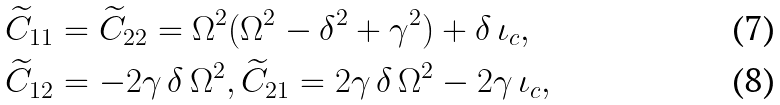Convert formula to latex. <formula><loc_0><loc_0><loc_500><loc_500>\widetilde { C } _ { 1 1 } & = \widetilde { C } _ { 2 2 } = \Omega ^ { 2 } ( \Omega ^ { 2 } - \delta ^ { 2 } + \gamma ^ { 2 } ) + \delta \, \iota _ { c } , \\ \widetilde { C } _ { 1 2 } & = - 2 \gamma \, \delta \, \Omega ^ { 2 } , \widetilde { C } _ { 2 1 } = 2 \gamma \, \delta \, \Omega ^ { 2 } - 2 \gamma \, \iota _ { c } ,</formula> 